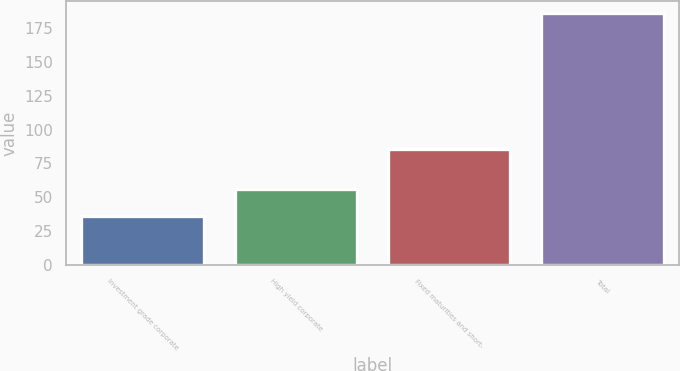<chart> <loc_0><loc_0><loc_500><loc_500><bar_chart><fcel>Investment grade corporate<fcel>High yield corporate<fcel>Fixed maturities and short-<fcel>Total<nl><fcel>36<fcel>56<fcel>86<fcel>186<nl></chart> 